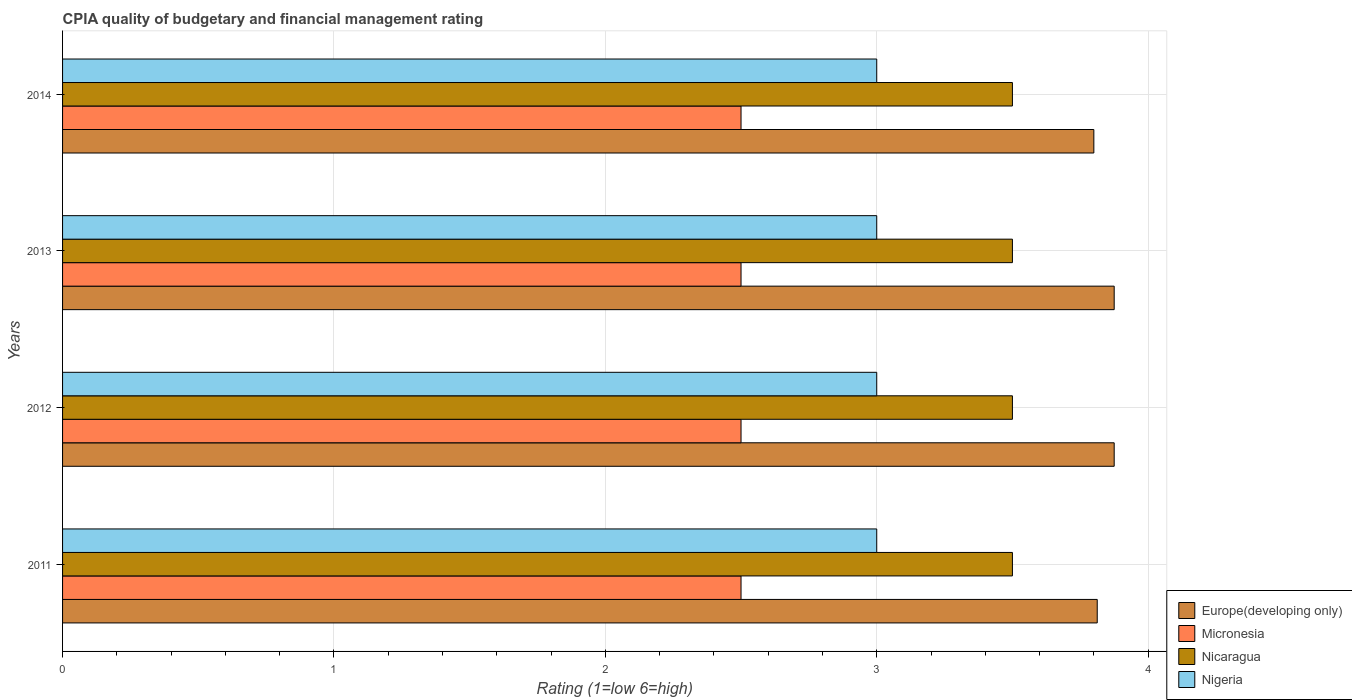How many bars are there on the 3rd tick from the top?
Your answer should be compact. 4. How many bars are there on the 4th tick from the bottom?
Your answer should be compact. 4. Across all years, what is the maximum CPIA rating in Nigeria?
Your response must be concise. 3. Across all years, what is the minimum CPIA rating in Micronesia?
Offer a very short reply. 2.5. In which year was the CPIA rating in Europe(developing only) minimum?
Make the answer very short. 2014. What is the total CPIA rating in Nigeria in the graph?
Make the answer very short. 12. What is the average CPIA rating in Nicaragua per year?
Your answer should be compact. 3.5. In the year 2012, what is the difference between the CPIA rating in Micronesia and CPIA rating in Europe(developing only)?
Offer a very short reply. -1.38. What is the ratio of the CPIA rating in Nigeria in 2013 to that in 2014?
Your answer should be very brief. 1. What is the difference between the highest and the lowest CPIA rating in Europe(developing only)?
Ensure brevity in your answer.  0.08. In how many years, is the CPIA rating in Europe(developing only) greater than the average CPIA rating in Europe(developing only) taken over all years?
Make the answer very short. 2. What does the 4th bar from the top in 2011 represents?
Offer a very short reply. Europe(developing only). What does the 1st bar from the bottom in 2013 represents?
Your answer should be very brief. Europe(developing only). How many bars are there?
Give a very brief answer. 16. Are the values on the major ticks of X-axis written in scientific E-notation?
Keep it short and to the point. No. Does the graph contain any zero values?
Ensure brevity in your answer.  No. Does the graph contain grids?
Offer a terse response. Yes. How are the legend labels stacked?
Offer a very short reply. Vertical. What is the title of the graph?
Your answer should be very brief. CPIA quality of budgetary and financial management rating. Does "Iraq" appear as one of the legend labels in the graph?
Provide a succinct answer. No. What is the label or title of the X-axis?
Make the answer very short. Rating (1=low 6=high). What is the label or title of the Y-axis?
Provide a succinct answer. Years. What is the Rating (1=low 6=high) in Europe(developing only) in 2011?
Your response must be concise. 3.81. What is the Rating (1=low 6=high) in Nicaragua in 2011?
Your answer should be compact. 3.5. What is the Rating (1=low 6=high) in Europe(developing only) in 2012?
Your response must be concise. 3.88. What is the Rating (1=low 6=high) of Nigeria in 2012?
Your answer should be very brief. 3. What is the Rating (1=low 6=high) in Europe(developing only) in 2013?
Your answer should be compact. 3.88. What is the Rating (1=low 6=high) in Micronesia in 2013?
Your answer should be very brief. 2.5. What is the Rating (1=low 6=high) of Nicaragua in 2013?
Your answer should be very brief. 3.5. What is the Rating (1=low 6=high) in Europe(developing only) in 2014?
Your answer should be very brief. 3.8. What is the Rating (1=low 6=high) of Micronesia in 2014?
Make the answer very short. 2.5. What is the Rating (1=low 6=high) in Nicaragua in 2014?
Provide a succinct answer. 3.5. Across all years, what is the maximum Rating (1=low 6=high) in Europe(developing only)?
Ensure brevity in your answer.  3.88. Across all years, what is the maximum Rating (1=low 6=high) in Nigeria?
Your response must be concise. 3. Across all years, what is the minimum Rating (1=low 6=high) of Europe(developing only)?
Ensure brevity in your answer.  3.8. Across all years, what is the minimum Rating (1=low 6=high) of Micronesia?
Ensure brevity in your answer.  2.5. Across all years, what is the minimum Rating (1=low 6=high) of Nicaragua?
Offer a very short reply. 3.5. What is the total Rating (1=low 6=high) of Europe(developing only) in the graph?
Offer a terse response. 15.36. What is the total Rating (1=low 6=high) in Micronesia in the graph?
Ensure brevity in your answer.  10. What is the difference between the Rating (1=low 6=high) of Europe(developing only) in 2011 and that in 2012?
Provide a short and direct response. -0.06. What is the difference between the Rating (1=low 6=high) of Nigeria in 2011 and that in 2012?
Ensure brevity in your answer.  0. What is the difference between the Rating (1=low 6=high) of Europe(developing only) in 2011 and that in 2013?
Offer a very short reply. -0.06. What is the difference between the Rating (1=low 6=high) in Micronesia in 2011 and that in 2013?
Make the answer very short. 0. What is the difference between the Rating (1=low 6=high) in Nicaragua in 2011 and that in 2013?
Ensure brevity in your answer.  0. What is the difference between the Rating (1=low 6=high) in Nigeria in 2011 and that in 2013?
Make the answer very short. 0. What is the difference between the Rating (1=low 6=high) in Europe(developing only) in 2011 and that in 2014?
Your response must be concise. 0.01. What is the difference between the Rating (1=low 6=high) in Micronesia in 2011 and that in 2014?
Keep it short and to the point. 0. What is the difference between the Rating (1=low 6=high) of Nicaragua in 2011 and that in 2014?
Offer a very short reply. 0. What is the difference between the Rating (1=low 6=high) of Europe(developing only) in 2012 and that in 2013?
Ensure brevity in your answer.  0. What is the difference between the Rating (1=low 6=high) of Nicaragua in 2012 and that in 2013?
Your answer should be compact. 0. What is the difference between the Rating (1=low 6=high) of Europe(developing only) in 2012 and that in 2014?
Give a very brief answer. 0.07. What is the difference between the Rating (1=low 6=high) of Nicaragua in 2012 and that in 2014?
Your answer should be compact. 0. What is the difference between the Rating (1=low 6=high) of Nigeria in 2012 and that in 2014?
Give a very brief answer. 0. What is the difference between the Rating (1=low 6=high) in Europe(developing only) in 2013 and that in 2014?
Your response must be concise. 0.07. What is the difference between the Rating (1=low 6=high) in Nigeria in 2013 and that in 2014?
Provide a succinct answer. 0. What is the difference between the Rating (1=low 6=high) of Europe(developing only) in 2011 and the Rating (1=low 6=high) of Micronesia in 2012?
Your answer should be compact. 1.31. What is the difference between the Rating (1=low 6=high) in Europe(developing only) in 2011 and the Rating (1=low 6=high) in Nicaragua in 2012?
Provide a short and direct response. 0.31. What is the difference between the Rating (1=low 6=high) of Europe(developing only) in 2011 and the Rating (1=low 6=high) of Nigeria in 2012?
Make the answer very short. 0.81. What is the difference between the Rating (1=low 6=high) of Micronesia in 2011 and the Rating (1=low 6=high) of Nicaragua in 2012?
Make the answer very short. -1. What is the difference between the Rating (1=low 6=high) in Nicaragua in 2011 and the Rating (1=low 6=high) in Nigeria in 2012?
Ensure brevity in your answer.  0.5. What is the difference between the Rating (1=low 6=high) of Europe(developing only) in 2011 and the Rating (1=low 6=high) of Micronesia in 2013?
Keep it short and to the point. 1.31. What is the difference between the Rating (1=low 6=high) in Europe(developing only) in 2011 and the Rating (1=low 6=high) in Nicaragua in 2013?
Ensure brevity in your answer.  0.31. What is the difference between the Rating (1=low 6=high) of Europe(developing only) in 2011 and the Rating (1=low 6=high) of Nigeria in 2013?
Keep it short and to the point. 0.81. What is the difference between the Rating (1=low 6=high) in Europe(developing only) in 2011 and the Rating (1=low 6=high) in Micronesia in 2014?
Provide a succinct answer. 1.31. What is the difference between the Rating (1=low 6=high) of Europe(developing only) in 2011 and the Rating (1=low 6=high) of Nicaragua in 2014?
Keep it short and to the point. 0.31. What is the difference between the Rating (1=low 6=high) in Europe(developing only) in 2011 and the Rating (1=low 6=high) in Nigeria in 2014?
Offer a terse response. 0.81. What is the difference between the Rating (1=low 6=high) of Nicaragua in 2011 and the Rating (1=low 6=high) of Nigeria in 2014?
Give a very brief answer. 0.5. What is the difference between the Rating (1=low 6=high) in Europe(developing only) in 2012 and the Rating (1=low 6=high) in Micronesia in 2013?
Your answer should be compact. 1.38. What is the difference between the Rating (1=low 6=high) in Europe(developing only) in 2012 and the Rating (1=low 6=high) in Nigeria in 2013?
Provide a short and direct response. 0.88. What is the difference between the Rating (1=low 6=high) in Micronesia in 2012 and the Rating (1=low 6=high) in Nigeria in 2013?
Your answer should be compact. -0.5. What is the difference between the Rating (1=low 6=high) in Europe(developing only) in 2012 and the Rating (1=low 6=high) in Micronesia in 2014?
Give a very brief answer. 1.38. What is the difference between the Rating (1=low 6=high) of Micronesia in 2012 and the Rating (1=low 6=high) of Nigeria in 2014?
Offer a very short reply. -0.5. What is the difference between the Rating (1=low 6=high) of Nicaragua in 2012 and the Rating (1=low 6=high) of Nigeria in 2014?
Your answer should be compact. 0.5. What is the difference between the Rating (1=low 6=high) of Europe(developing only) in 2013 and the Rating (1=low 6=high) of Micronesia in 2014?
Provide a short and direct response. 1.38. What is the difference between the Rating (1=low 6=high) in Europe(developing only) in 2013 and the Rating (1=low 6=high) in Nicaragua in 2014?
Your response must be concise. 0.38. What is the difference between the Rating (1=low 6=high) in Europe(developing only) in 2013 and the Rating (1=low 6=high) in Nigeria in 2014?
Make the answer very short. 0.88. What is the difference between the Rating (1=low 6=high) of Micronesia in 2013 and the Rating (1=low 6=high) of Nicaragua in 2014?
Ensure brevity in your answer.  -1. What is the difference between the Rating (1=low 6=high) of Nicaragua in 2013 and the Rating (1=low 6=high) of Nigeria in 2014?
Your response must be concise. 0.5. What is the average Rating (1=low 6=high) of Europe(developing only) per year?
Offer a terse response. 3.84. What is the average Rating (1=low 6=high) of Nigeria per year?
Offer a terse response. 3. In the year 2011, what is the difference between the Rating (1=low 6=high) of Europe(developing only) and Rating (1=low 6=high) of Micronesia?
Keep it short and to the point. 1.31. In the year 2011, what is the difference between the Rating (1=low 6=high) of Europe(developing only) and Rating (1=low 6=high) of Nicaragua?
Offer a terse response. 0.31. In the year 2011, what is the difference between the Rating (1=low 6=high) of Europe(developing only) and Rating (1=low 6=high) of Nigeria?
Give a very brief answer. 0.81. In the year 2011, what is the difference between the Rating (1=low 6=high) of Micronesia and Rating (1=low 6=high) of Nigeria?
Provide a short and direct response. -0.5. In the year 2011, what is the difference between the Rating (1=low 6=high) in Nicaragua and Rating (1=low 6=high) in Nigeria?
Your answer should be very brief. 0.5. In the year 2012, what is the difference between the Rating (1=low 6=high) in Europe(developing only) and Rating (1=low 6=high) in Micronesia?
Make the answer very short. 1.38. In the year 2012, what is the difference between the Rating (1=low 6=high) of Europe(developing only) and Rating (1=low 6=high) of Nicaragua?
Your answer should be very brief. 0.38. In the year 2012, what is the difference between the Rating (1=low 6=high) of Europe(developing only) and Rating (1=low 6=high) of Nigeria?
Your answer should be very brief. 0.88. In the year 2012, what is the difference between the Rating (1=low 6=high) in Micronesia and Rating (1=low 6=high) in Nicaragua?
Make the answer very short. -1. In the year 2013, what is the difference between the Rating (1=low 6=high) in Europe(developing only) and Rating (1=low 6=high) in Micronesia?
Your answer should be very brief. 1.38. In the year 2013, what is the difference between the Rating (1=low 6=high) of Europe(developing only) and Rating (1=low 6=high) of Nicaragua?
Your answer should be compact. 0.38. In the year 2013, what is the difference between the Rating (1=low 6=high) of Europe(developing only) and Rating (1=low 6=high) of Nigeria?
Give a very brief answer. 0.88. In the year 2013, what is the difference between the Rating (1=low 6=high) of Micronesia and Rating (1=low 6=high) of Nigeria?
Provide a succinct answer. -0.5. In the year 2013, what is the difference between the Rating (1=low 6=high) of Nicaragua and Rating (1=low 6=high) of Nigeria?
Give a very brief answer. 0.5. In the year 2014, what is the difference between the Rating (1=low 6=high) in Europe(developing only) and Rating (1=low 6=high) in Nicaragua?
Ensure brevity in your answer.  0.3. In the year 2014, what is the difference between the Rating (1=low 6=high) of Europe(developing only) and Rating (1=low 6=high) of Nigeria?
Offer a very short reply. 0.8. In the year 2014, what is the difference between the Rating (1=low 6=high) of Micronesia and Rating (1=low 6=high) of Nicaragua?
Give a very brief answer. -1. In the year 2014, what is the difference between the Rating (1=low 6=high) of Nicaragua and Rating (1=low 6=high) of Nigeria?
Your response must be concise. 0.5. What is the ratio of the Rating (1=low 6=high) in Europe(developing only) in 2011 to that in 2012?
Provide a short and direct response. 0.98. What is the ratio of the Rating (1=low 6=high) in Nigeria in 2011 to that in 2012?
Offer a terse response. 1. What is the ratio of the Rating (1=low 6=high) of Europe(developing only) in 2011 to that in 2013?
Offer a terse response. 0.98. What is the ratio of the Rating (1=low 6=high) of Micronesia in 2011 to that in 2013?
Make the answer very short. 1. What is the ratio of the Rating (1=low 6=high) in Nicaragua in 2011 to that in 2013?
Your response must be concise. 1. What is the ratio of the Rating (1=low 6=high) of Europe(developing only) in 2011 to that in 2014?
Provide a short and direct response. 1. What is the ratio of the Rating (1=low 6=high) of Micronesia in 2011 to that in 2014?
Provide a succinct answer. 1. What is the ratio of the Rating (1=low 6=high) in Nicaragua in 2011 to that in 2014?
Your answer should be very brief. 1. What is the ratio of the Rating (1=low 6=high) in Nigeria in 2011 to that in 2014?
Make the answer very short. 1. What is the ratio of the Rating (1=low 6=high) of Europe(developing only) in 2012 to that in 2013?
Provide a succinct answer. 1. What is the ratio of the Rating (1=low 6=high) in Micronesia in 2012 to that in 2013?
Give a very brief answer. 1. What is the ratio of the Rating (1=low 6=high) in Nicaragua in 2012 to that in 2013?
Provide a short and direct response. 1. What is the ratio of the Rating (1=low 6=high) in Europe(developing only) in 2012 to that in 2014?
Provide a succinct answer. 1.02. What is the ratio of the Rating (1=low 6=high) of Nicaragua in 2012 to that in 2014?
Your answer should be very brief. 1. What is the ratio of the Rating (1=low 6=high) of Nigeria in 2012 to that in 2014?
Make the answer very short. 1. What is the ratio of the Rating (1=low 6=high) in Europe(developing only) in 2013 to that in 2014?
Offer a terse response. 1.02. What is the ratio of the Rating (1=low 6=high) in Micronesia in 2013 to that in 2014?
Offer a terse response. 1. What is the ratio of the Rating (1=low 6=high) of Nicaragua in 2013 to that in 2014?
Offer a terse response. 1. What is the difference between the highest and the second highest Rating (1=low 6=high) in Micronesia?
Your answer should be very brief. 0. What is the difference between the highest and the lowest Rating (1=low 6=high) of Europe(developing only)?
Offer a very short reply. 0.07. What is the difference between the highest and the lowest Rating (1=low 6=high) in Micronesia?
Ensure brevity in your answer.  0. What is the difference between the highest and the lowest Rating (1=low 6=high) in Nigeria?
Offer a very short reply. 0. 